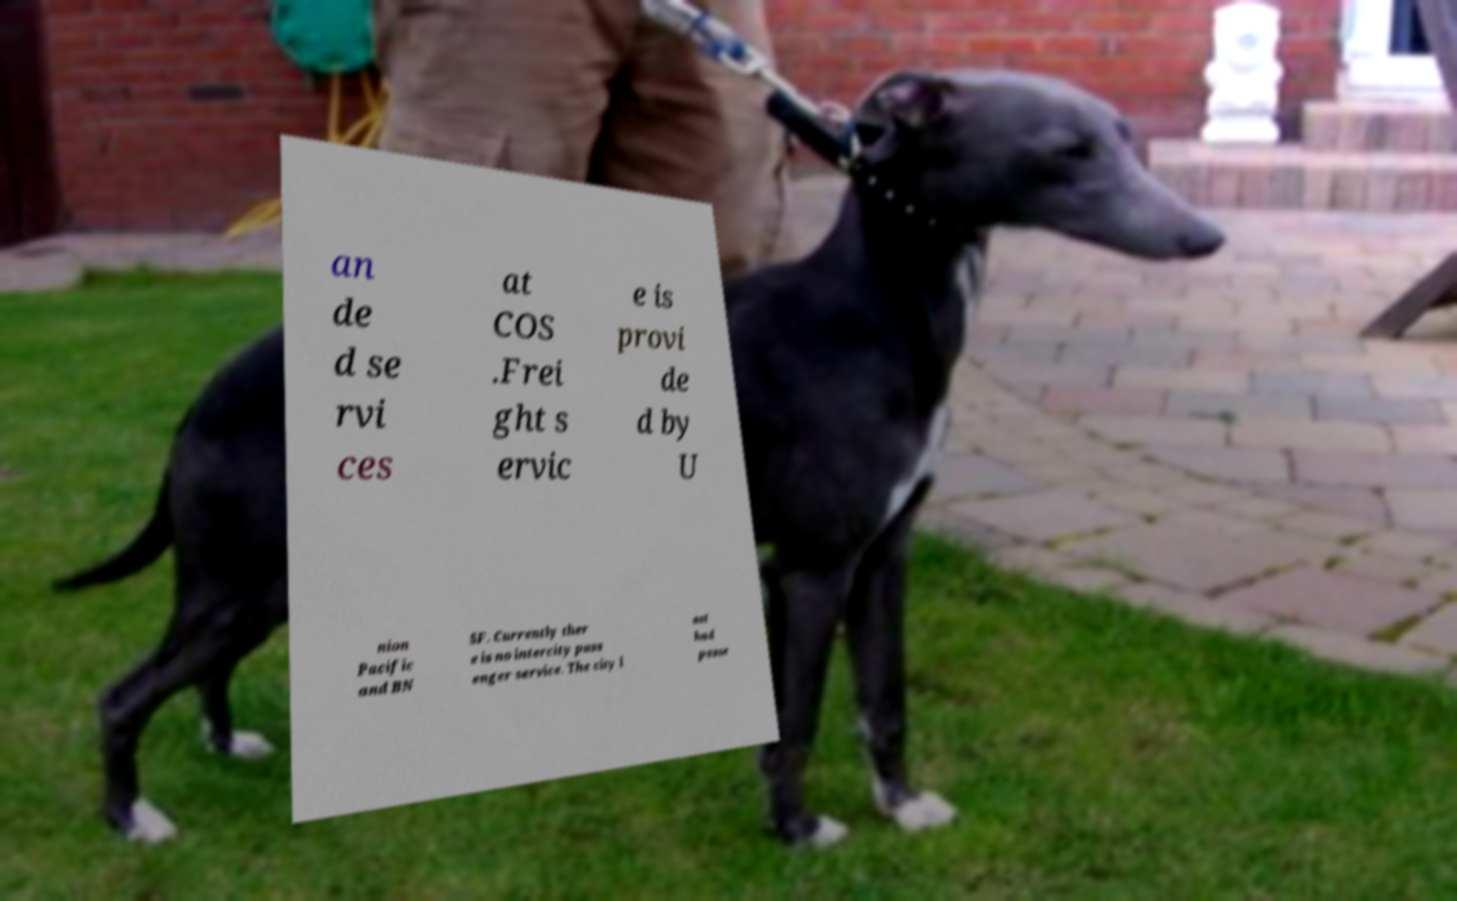Could you extract and type out the text from this image? an de d se rvi ces at COS .Frei ght s ervic e is provi de d by U nion Pacific and BN SF. Currently ther e is no intercity pass enger service. The city l ast had passe 